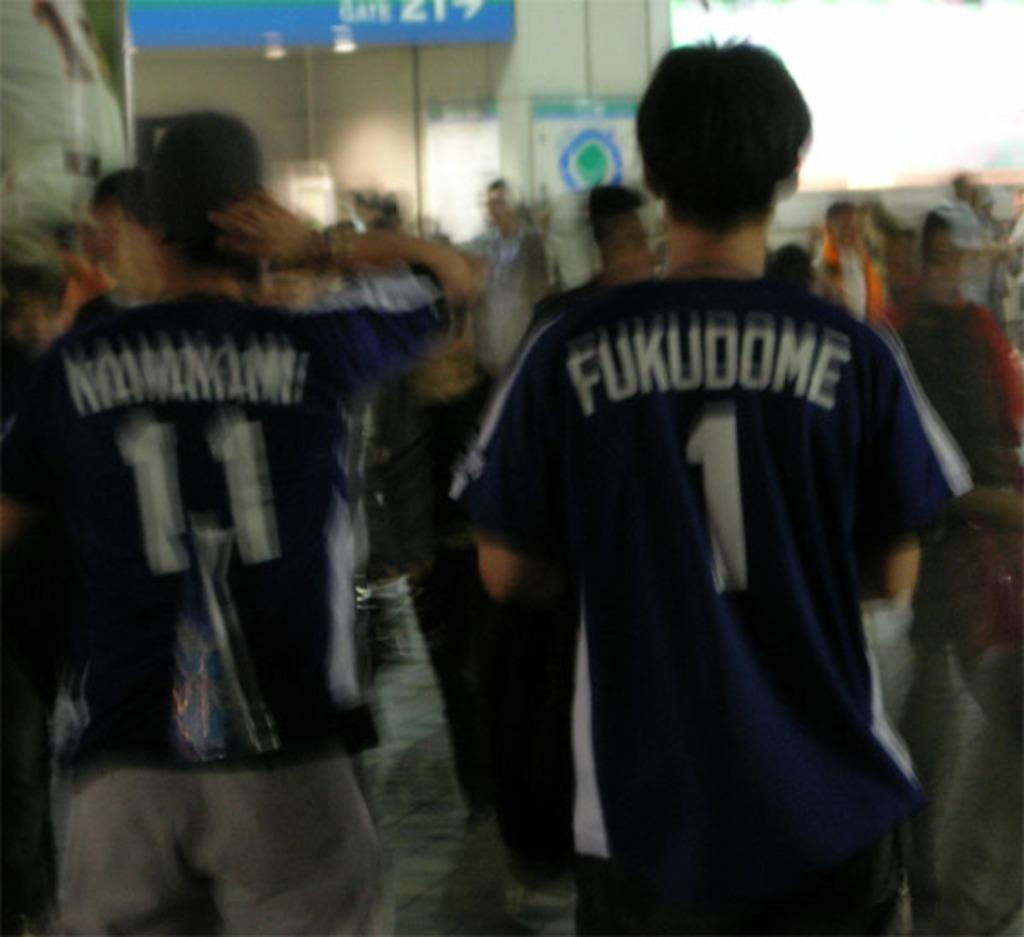<image>
Provide a brief description of the given image. Two young men wear jerseys with the number 11 and the number 1 on them. 